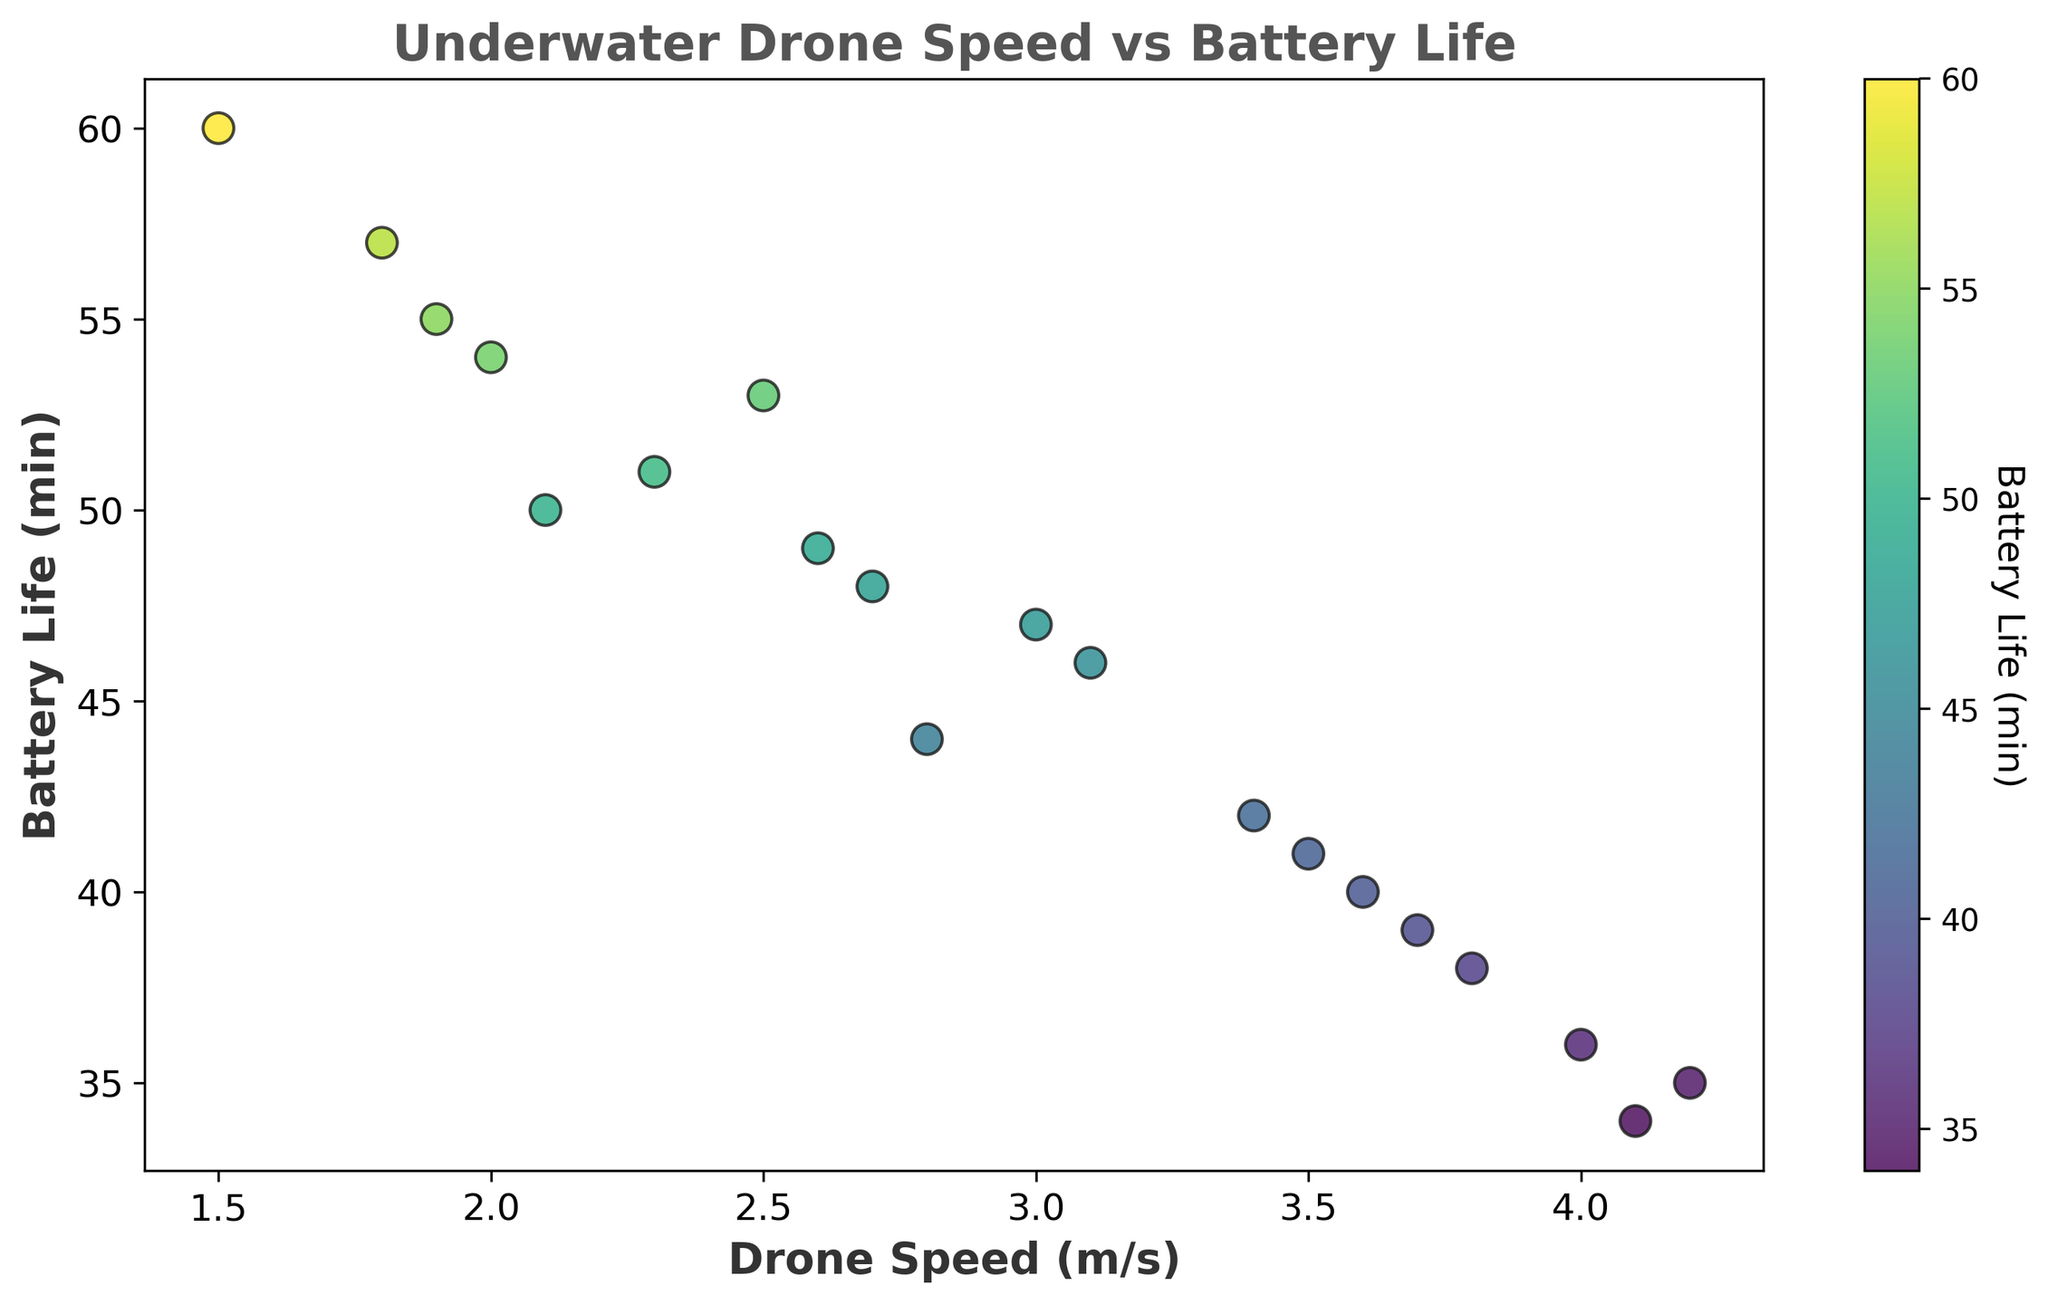What is the general trend observed between drone speed and battery life? By looking at the scatter plot, it is evident that as the drone speed increases, the battery life tends to decrease. This shows a negative correlation between the two variables.
Answer: Negative correlation Which drone has the highest speed and what is its battery life? The scatter plot indicates the drone with the highest speed is at (4.2, 35). Therefore, the drone with the highest speed has a battery life of 35 minutes.
Answer: 35 minutes Which range of drone speeds generally corresponds to higher battery life? Observing the plot, drones with speeds between 1.5 m/s and 2.5 m/s mostly have battery lives greater than 50 minutes, indicating higher battery life.
Answer: 1.5 to 2.5 m/s What can you infer about the drone with the speed of 4.1 m/s? The scatter plot shows that at the speed of 4.1 m/s, the drone has a battery life of 34 minutes. This suggests that drones with higher speeds tend to have lower battery life.
Answer: 34 minutes How does the median battery life compare for drones with speeds higher than 3 m/s versus lower than 3 m/s? First, identify the battery life for drones with speeds higher than 3 m/s and separately for those lower than 3 m/s from the scatter plot. Then, calculate the median for both groups. Drones higher than 3 m/s: [47, 44, 35, 38, 46, 40, 39, 36, 42, 34, 41] -> Median = 39.5. Drones lower than 3 m/s: [50, 60, 53, 48, 55, 54, 57, 51, 49] -> Median = 53. Therefore, the median battery life is greater for drones with speeds lower than 3 m/s.
Answer: Lower than 3 m/s has higher median What are the battery life ranges covered by the color map in the scatter plot? The color map on the scatter plot uses shades of color corresponding to battery life. By observing the color bar, it can be inferred that the battery life ranges from approximately 34 to 60 minutes.
Answer: 34 to 60 minutes Which drone has the longest battery life and what is its speed? The scatter plot shows the drone with the highest battery life is at (1.5, 60). Therefore, the drone with the longest battery life has a speed of 1.5 m/s.
Answer: 1.5 m/s If a drone has a battery life of about 50 minutes, what range of speeds can it be expected to run at? By looking at the points around the 50-minute mark on the scatter plot, these drones have speeds mostly between 2.0 m/s and 2.5 m/s.
Answer: 2.0 to 2.5 m/s Which drone has the lowest battery life and what is its speed? The scatter plot shows the drone with the lowest battery life is at (4.1, 34). Therefore, the drone with the lowest battery life has a speed of 4.1 m/s.
Answer: 4.1 m/s 